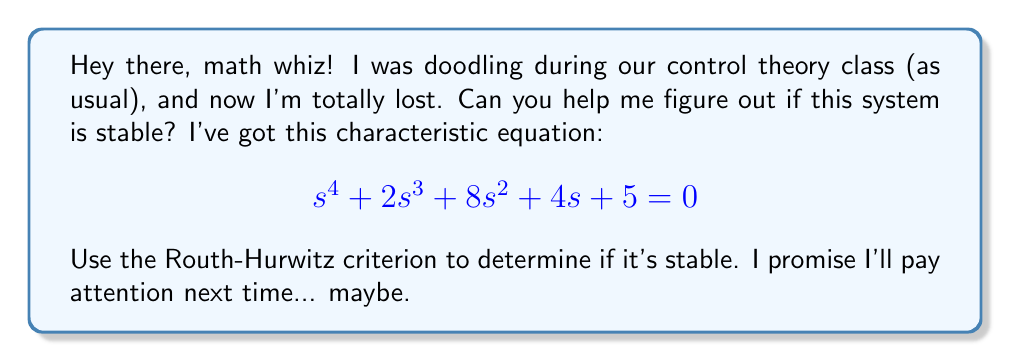Help me with this question. Alright, class clown, let's break this down step-by-step:

1) First, we need to create the Routh array. The coefficients of our characteristic equation are:
   $$a_0 = 1, a_1 = 2, a_2 = 8, a_3 = 4, a_4 = 5$$

2) Now, let's set up the array:

   $$\begin{array}{c|cc}
   s^4 & 1 & 8 & 5 \\
   s^3 & 2 & 4 & 0 \\
   s^2 & b_1 & b_2 & \\
   s^1 & c_1 & & \\
   s^0 & d_1 & &
   \end{array}$$

3) We need to calculate $b_1$, $b_2$, $c_1$, and $d_1$:

   $b_1 = \frac{(2)(8) - (1)(4)}{2} = 6$
   
   $b_2 = \frac{(2)(5) - (1)(0)}{2} = 5$

   $c_1 = \frac{(6)(4) - (2)(5)}{6} = 3$

   $d_1 = \frac{(3)(5) - (6)(0)}{3} = 5$

4) Our completed Routh array looks like this:

   $$\begin{array}{c|cc}
   s^4 & 1 & 8 & 5 \\
   s^3 & 2 & 4 & 0 \\
   s^2 & 6 & 5 & \\
   s^1 & 3 & & \\
   s^0 & 5 & &
   \end{array}$$

5) For stability, all elements in the first column of the Routh array must have the same sign (all positive or all negative).

6) In this case, all elements in the first column (1, 2, 6, 3, 5) are positive.

Therefore, the system is stable.
Answer: The system is stable. 